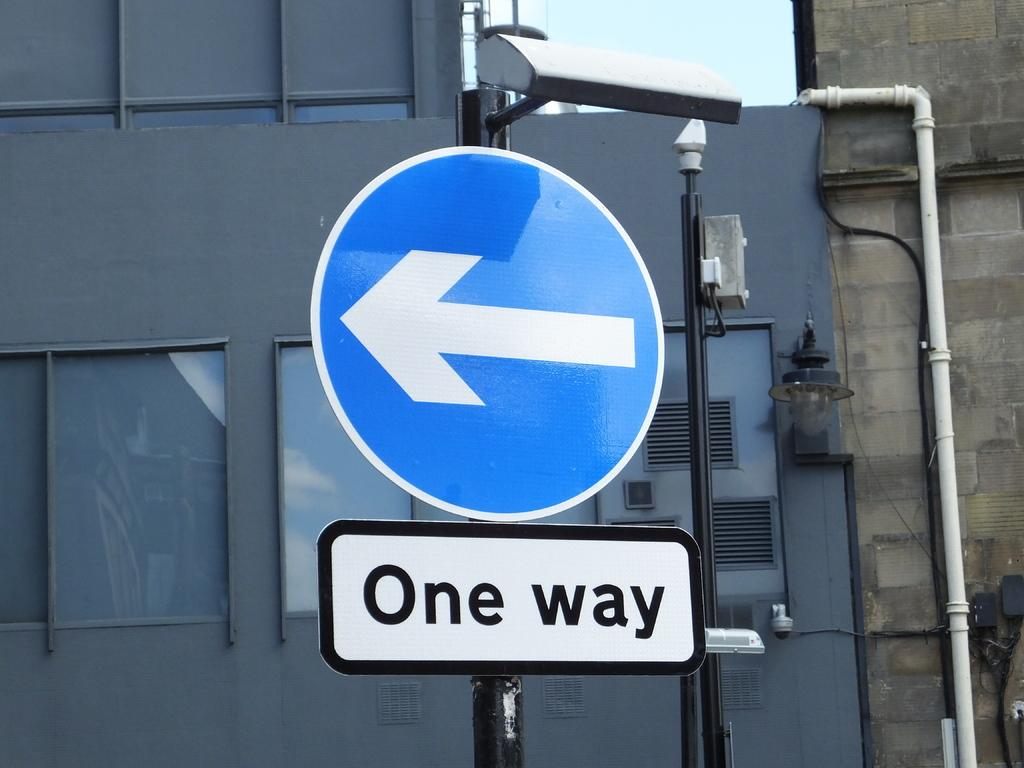<image>
Create a compact narrative representing the image presented. A sign that says One Way below an arrow sign. 